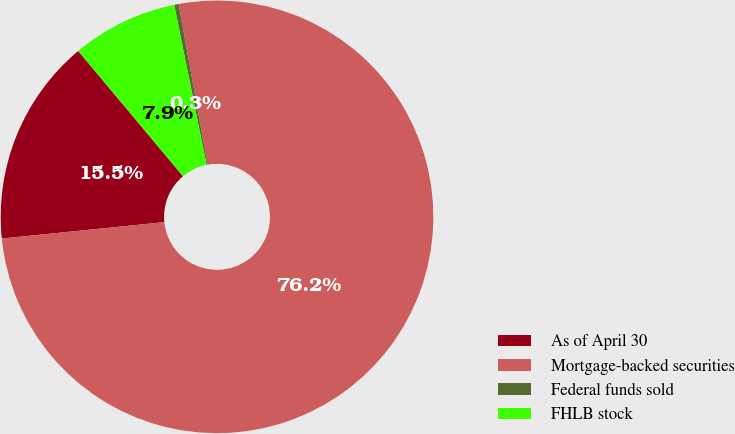Convert chart. <chart><loc_0><loc_0><loc_500><loc_500><pie_chart><fcel>As of April 30<fcel>Mortgage-backed securities<fcel>Federal funds sold<fcel>FHLB stock<nl><fcel>15.51%<fcel>76.24%<fcel>0.33%<fcel>7.92%<nl></chart> 